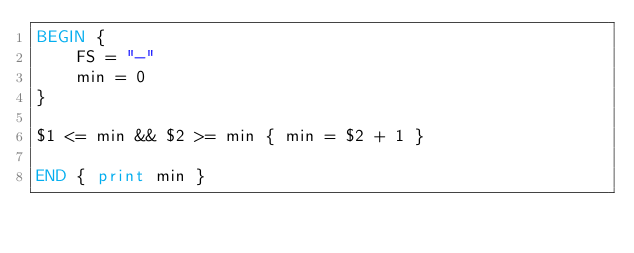Convert code to text. <code><loc_0><loc_0><loc_500><loc_500><_Awk_>BEGIN {
    FS = "-"
    min = 0
}

$1 <= min && $2 >= min { min = $2 + 1 }

END { print min }
</code> 